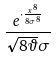Convert formula to latex. <formula><loc_0><loc_0><loc_500><loc_500>\frac { e ^ { \cdot \frac { x ^ { 8 } } { 8 \sigma ^ { 8 } } } } { \sqrt { 8 \vartheta } \sigma }</formula> 